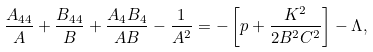<formula> <loc_0><loc_0><loc_500><loc_500>\frac { A _ { 4 4 } } { A } + \frac { B _ { 4 4 } } { B } + \frac { A _ { 4 } B _ { 4 } } { A B } - \frac { 1 } { A ^ { 2 } } = - \left [ p + \frac { K ^ { 2 } } { 2 B ^ { 2 } C ^ { 2 } } \right ] - \Lambda ,</formula> 